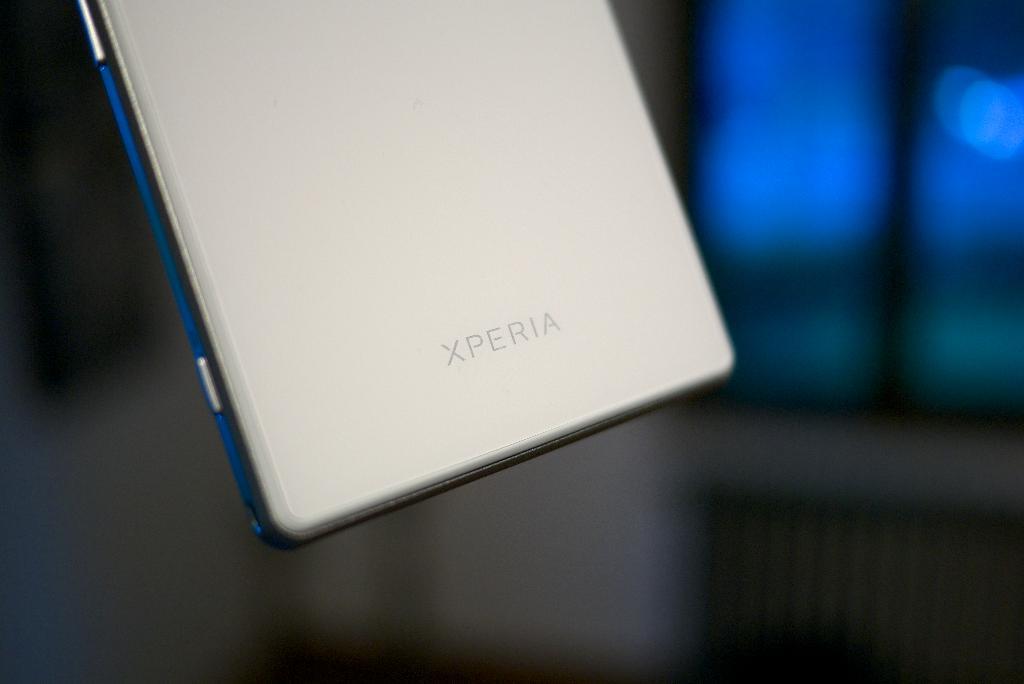What brand is this?
Keep it short and to the point. Xperia. 